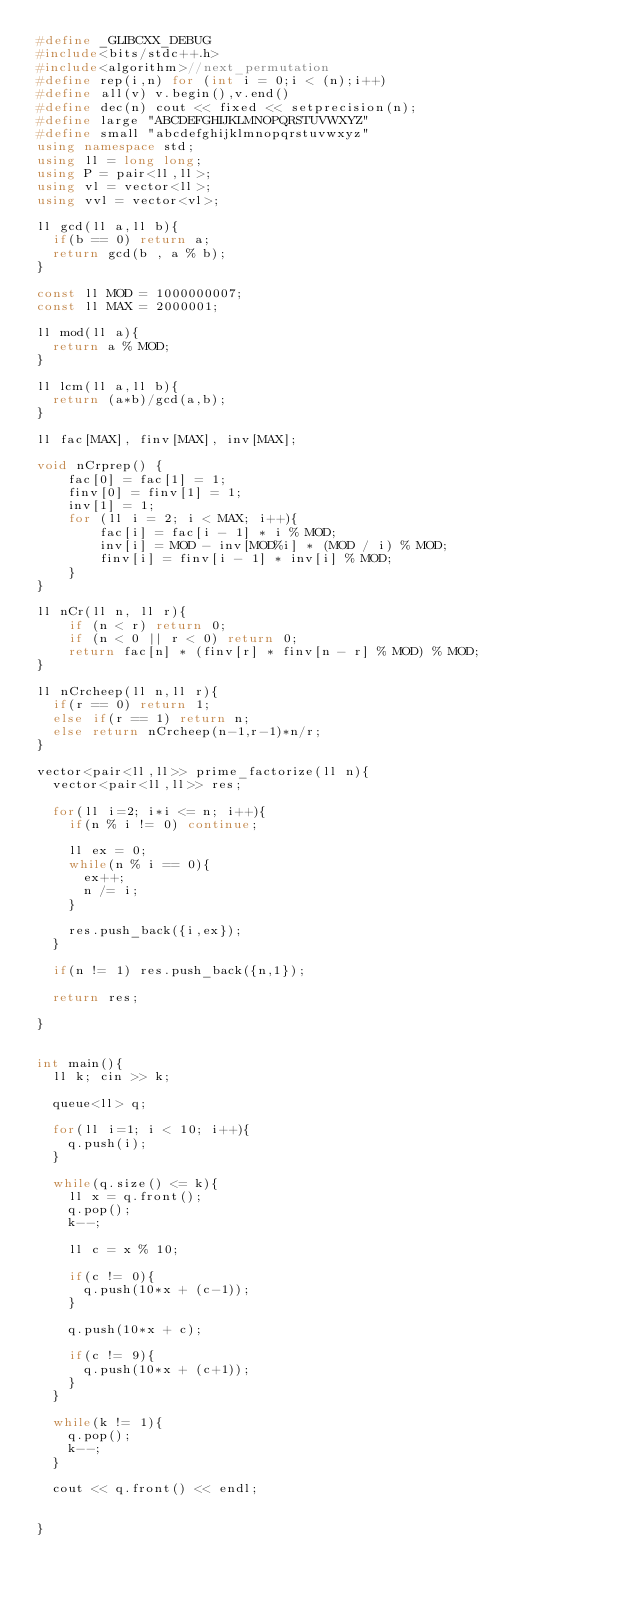Convert code to text. <code><loc_0><loc_0><loc_500><loc_500><_C++_>#define _GLIBCXX_DEBUG
#include<bits/stdc++.h>
#include<algorithm>//next_permutation
#define rep(i,n) for (int i = 0;i < (n);i++)
#define all(v) v.begin(),v.end()
#define dec(n) cout << fixed << setprecision(n);
#define large "ABCDEFGHIJKLMNOPQRSTUVWXYZ"
#define small "abcdefghijklmnopqrstuvwxyz"
using namespace std;
using ll = long long;
using P = pair<ll,ll>;
using vl = vector<ll>;
using vvl = vector<vl>;

ll gcd(ll a,ll b){
  if(b == 0) return a;
  return gcd(b , a % b);
}

const ll MOD = 1000000007;
const ll MAX = 2000001;

ll mod(ll a){
  return a % MOD;
}

ll lcm(ll a,ll b){
  return (a*b)/gcd(a,b);
}

ll fac[MAX], finv[MAX], inv[MAX];

void nCrprep() {
    fac[0] = fac[1] = 1;
    finv[0] = finv[1] = 1;
    inv[1] = 1;
    for (ll i = 2; i < MAX; i++){
        fac[i] = fac[i - 1] * i % MOD;
        inv[i] = MOD - inv[MOD%i] * (MOD / i) % MOD;
        finv[i] = finv[i - 1] * inv[i] % MOD;
    }
}

ll nCr(ll n, ll r){
    if (n < r) return 0;
    if (n < 0 || r < 0) return 0;
    return fac[n] * (finv[r] * finv[n - r] % MOD) % MOD;
}

ll nCrcheep(ll n,ll r){
  if(r == 0) return 1;
  else if(r == 1) return n;
  else return nCrcheep(n-1,r-1)*n/r;
}

vector<pair<ll,ll>> prime_factorize(ll n){
  vector<pair<ll,ll>> res;
  
  for(ll i=2; i*i <= n; i++){
    if(n % i != 0) continue;
    
    ll ex = 0;
    while(n % i == 0){
      ex++;
      n /= i;
    }
    
    res.push_back({i,ex});
  }
  
  if(n != 1) res.push_back({n,1});
  
  return res;
  
}


int main(){
  ll k; cin >> k;
  
  queue<ll> q;
  
  for(ll i=1; i < 10; i++){
    q.push(i);
  }
  
  while(q.size() <= k){
    ll x = q.front();
    q.pop(); 
    k--;
    
    ll c = x % 10;
    
    if(c != 0){
      q.push(10*x + (c-1));
    }
    
    q.push(10*x + c);
    
    if(c != 9){
      q.push(10*x + (c+1));
    }
  }
  
  while(k != 1){
    q.pop();
    k--;
  }
  
  cout << q.front() << endl;
  
  
}</code> 